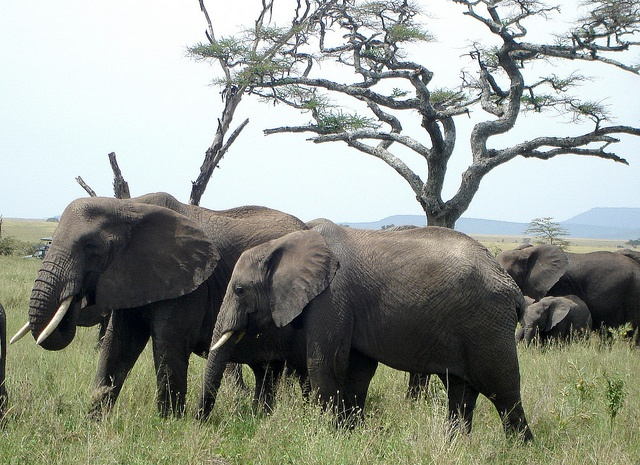Describe the objects in this image and their specific colors. I can see elephant in white, black, gray, and darkgray tones, elephant in white, black, gray, and darkgray tones, elephant in white, black, gray, and darkgray tones, and elephant in white, black, gray, and darkgray tones in this image. 